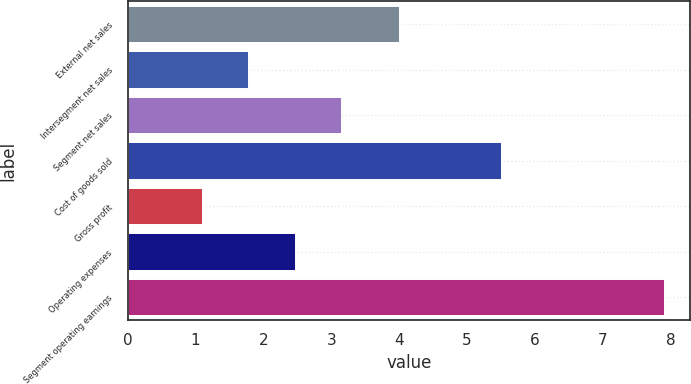Convert chart. <chart><loc_0><loc_0><loc_500><loc_500><bar_chart><fcel>External net sales<fcel>Intersegment net sales<fcel>Segment net sales<fcel>Cost of goods sold<fcel>Gross profit<fcel>Operating expenses<fcel>Segment operating earnings<nl><fcel>4<fcel>1.78<fcel>3.14<fcel>5.5<fcel>1.1<fcel>2.46<fcel>7.9<nl></chart> 